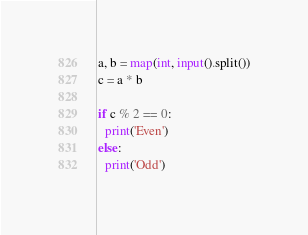Convert code to text. <code><loc_0><loc_0><loc_500><loc_500><_Python_>a, b = map(int, input().split())
c = a * b
 
if c % 2 == 0:
  print('Even')
else:
  print('Odd')</code> 